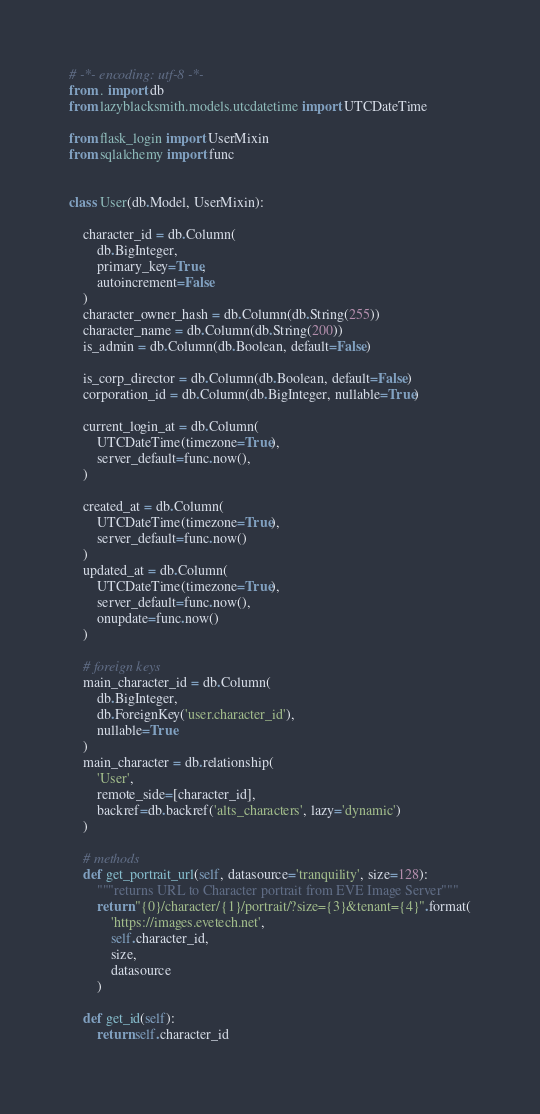<code> <loc_0><loc_0><loc_500><loc_500><_Python_># -*- encoding: utf-8 -*-
from . import db
from lazyblacksmith.models.utcdatetime import UTCDateTime

from flask_login import UserMixin
from sqlalchemy import func


class User(db.Model, UserMixin):

    character_id = db.Column(
        db.BigInteger,
        primary_key=True,
        autoincrement=False
    )
    character_owner_hash = db.Column(db.String(255))
    character_name = db.Column(db.String(200))
    is_admin = db.Column(db.Boolean, default=False)

    is_corp_director = db.Column(db.Boolean, default=False)
    corporation_id = db.Column(db.BigInteger, nullable=True)

    current_login_at = db.Column(
        UTCDateTime(timezone=True),
        server_default=func.now(),
    )

    created_at = db.Column(
        UTCDateTime(timezone=True),
        server_default=func.now()
    )
    updated_at = db.Column(
        UTCDateTime(timezone=True),
        server_default=func.now(),
        onupdate=func.now()
    )

    # foreign keys
    main_character_id = db.Column(
        db.BigInteger,
        db.ForeignKey('user.character_id'),
        nullable=True
    )
    main_character = db.relationship(
        'User',
        remote_side=[character_id],
        backref=db.backref('alts_characters', lazy='dynamic')
    )

    # methods
    def get_portrait_url(self, datasource='tranquility', size=128):
        """returns URL to Character portrait from EVE Image Server"""
        return "{0}/character/{1}/portrait/?size={3}&tenant={4}".format(
            'https://images.evetech.net',
            self.character_id,
            size,
            datasource
        )

    def get_id(self):
        return self.character_id
</code> 